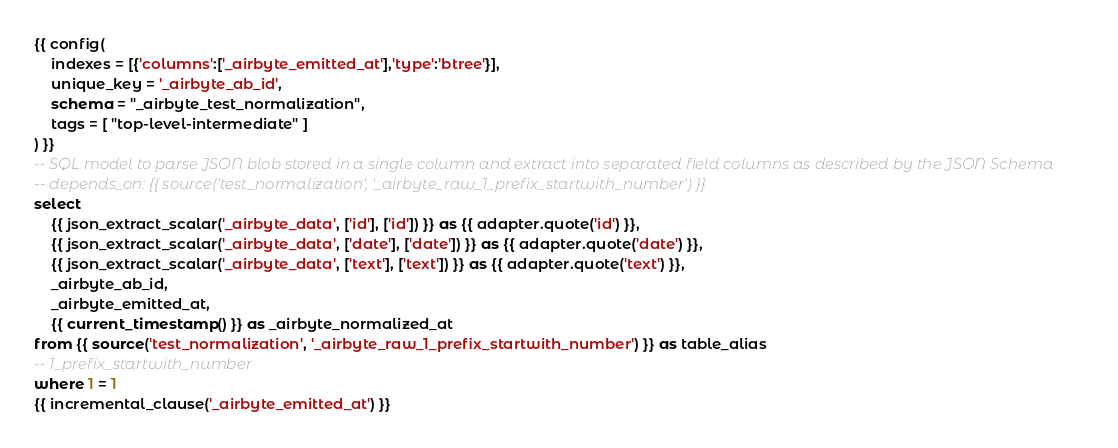Convert code to text. <code><loc_0><loc_0><loc_500><loc_500><_SQL_>{{ config(
    indexes = [{'columns':['_airbyte_emitted_at'],'type':'btree'}],
    unique_key = '_airbyte_ab_id',
    schema = "_airbyte_test_normalization",
    tags = [ "top-level-intermediate" ]
) }}
-- SQL model to parse JSON blob stored in a single column and extract into separated field columns as described by the JSON Schema
-- depends_on: {{ source('test_normalization', '_airbyte_raw_1_prefix_startwith_number') }}
select
    {{ json_extract_scalar('_airbyte_data', ['id'], ['id']) }} as {{ adapter.quote('id') }},
    {{ json_extract_scalar('_airbyte_data', ['date'], ['date']) }} as {{ adapter.quote('date') }},
    {{ json_extract_scalar('_airbyte_data', ['text'], ['text']) }} as {{ adapter.quote('text') }},
    _airbyte_ab_id,
    _airbyte_emitted_at,
    {{ current_timestamp() }} as _airbyte_normalized_at
from {{ source('test_normalization', '_airbyte_raw_1_prefix_startwith_number') }} as table_alias
-- 1_prefix_startwith_number
where 1 = 1
{{ incremental_clause('_airbyte_emitted_at') }}

</code> 